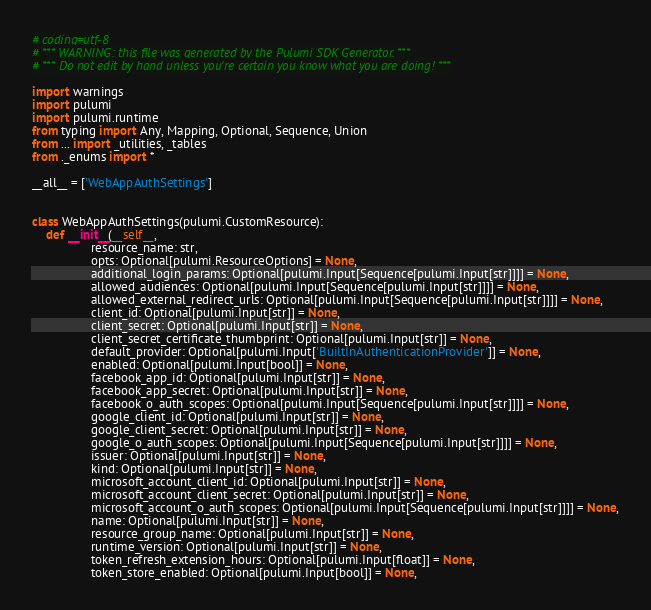<code> <loc_0><loc_0><loc_500><loc_500><_Python_># coding=utf-8
# *** WARNING: this file was generated by the Pulumi SDK Generator. ***
# *** Do not edit by hand unless you're certain you know what you are doing! ***

import warnings
import pulumi
import pulumi.runtime
from typing import Any, Mapping, Optional, Sequence, Union
from ... import _utilities, _tables
from ._enums import *

__all__ = ['WebAppAuthSettings']


class WebAppAuthSettings(pulumi.CustomResource):
    def __init__(__self__,
                 resource_name: str,
                 opts: Optional[pulumi.ResourceOptions] = None,
                 additional_login_params: Optional[pulumi.Input[Sequence[pulumi.Input[str]]]] = None,
                 allowed_audiences: Optional[pulumi.Input[Sequence[pulumi.Input[str]]]] = None,
                 allowed_external_redirect_urls: Optional[pulumi.Input[Sequence[pulumi.Input[str]]]] = None,
                 client_id: Optional[pulumi.Input[str]] = None,
                 client_secret: Optional[pulumi.Input[str]] = None,
                 client_secret_certificate_thumbprint: Optional[pulumi.Input[str]] = None,
                 default_provider: Optional[pulumi.Input['BuiltInAuthenticationProvider']] = None,
                 enabled: Optional[pulumi.Input[bool]] = None,
                 facebook_app_id: Optional[pulumi.Input[str]] = None,
                 facebook_app_secret: Optional[pulumi.Input[str]] = None,
                 facebook_o_auth_scopes: Optional[pulumi.Input[Sequence[pulumi.Input[str]]]] = None,
                 google_client_id: Optional[pulumi.Input[str]] = None,
                 google_client_secret: Optional[pulumi.Input[str]] = None,
                 google_o_auth_scopes: Optional[pulumi.Input[Sequence[pulumi.Input[str]]]] = None,
                 issuer: Optional[pulumi.Input[str]] = None,
                 kind: Optional[pulumi.Input[str]] = None,
                 microsoft_account_client_id: Optional[pulumi.Input[str]] = None,
                 microsoft_account_client_secret: Optional[pulumi.Input[str]] = None,
                 microsoft_account_o_auth_scopes: Optional[pulumi.Input[Sequence[pulumi.Input[str]]]] = None,
                 name: Optional[pulumi.Input[str]] = None,
                 resource_group_name: Optional[pulumi.Input[str]] = None,
                 runtime_version: Optional[pulumi.Input[str]] = None,
                 token_refresh_extension_hours: Optional[pulumi.Input[float]] = None,
                 token_store_enabled: Optional[pulumi.Input[bool]] = None,</code> 